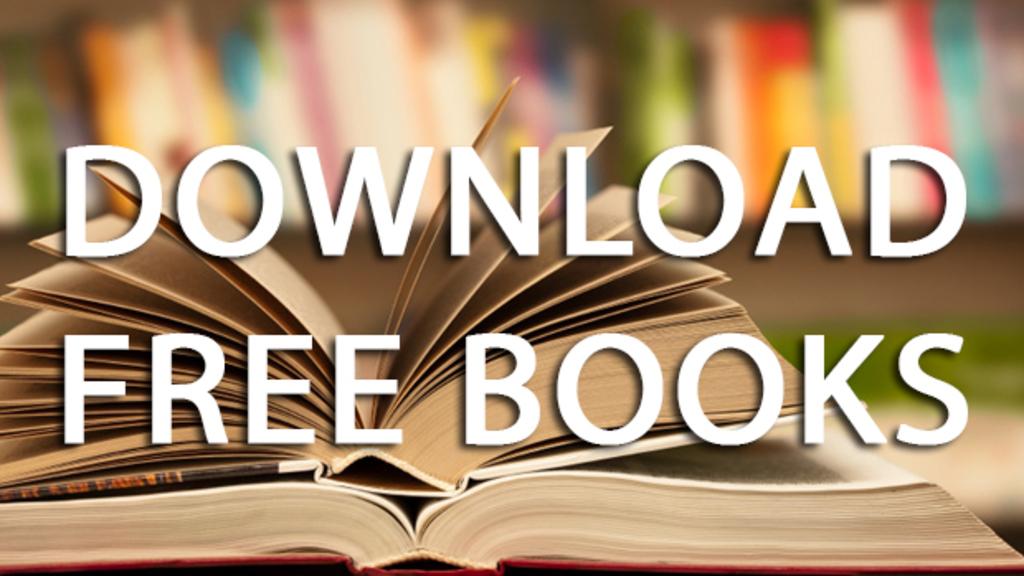What can you download for free?
Offer a terse response. Books. 